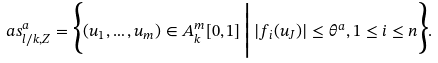Convert formula to latex. <formula><loc_0><loc_0><loc_500><loc_500>a s _ { l / k , Z } ^ { a } = \Big \{ ( u _ { 1 } , \dots , u _ { m } ) \in A _ { k } ^ { m } [ 0 , 1 ] \, \Big | \, | f _ { i } ( u _ { J } ) | \leq \theta ^ { a } , 1 \leq i \leq n \Big \} .</formula> 